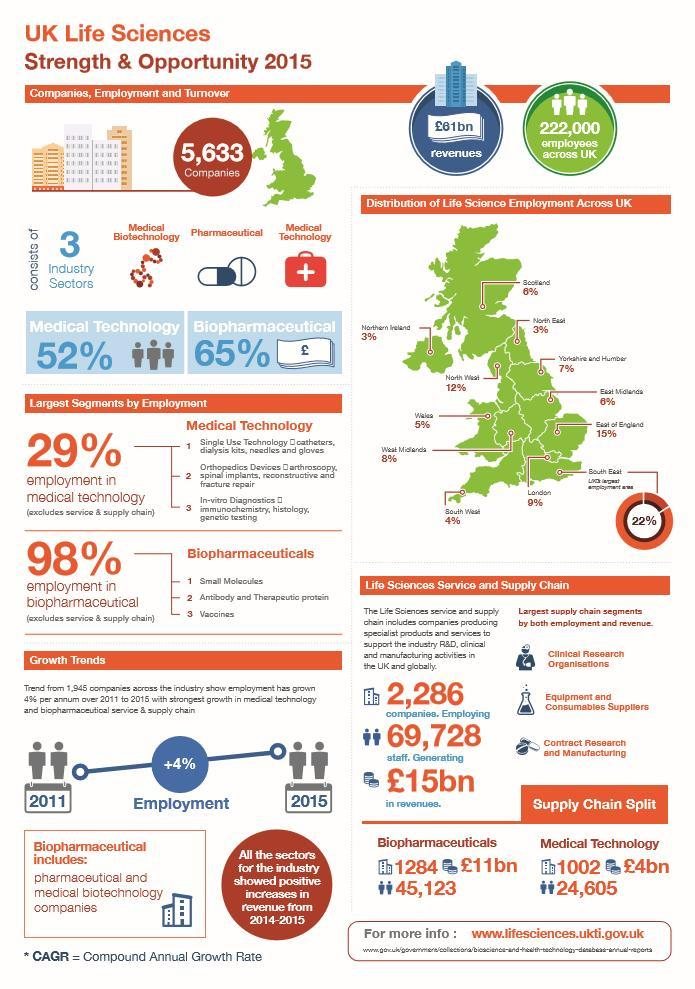How many biopharmaceutical companies were there in UK in 2015?
Answer the question with a short phrase. 1284 What is the revenue generated by life science services in UK in 2015? £15bn What percentage of life science employment is seen in Norther Ireland in 2015? 3% How many people were working in Medical Technology companies in UK in 2015? 24,605 What is the revenue generated by biopharmaceutical companies in UK in 2015? £11bn How many people were working in  biopharmaceutical companies in UK in 2015? 45,123 How many people were working in life science services companies in UK in 2015? 69,728 What percentage of life science employment is seen in West Midlands in 2015? 8% How many life science services & supply chain companies were there in UK in 2015? 2,286 